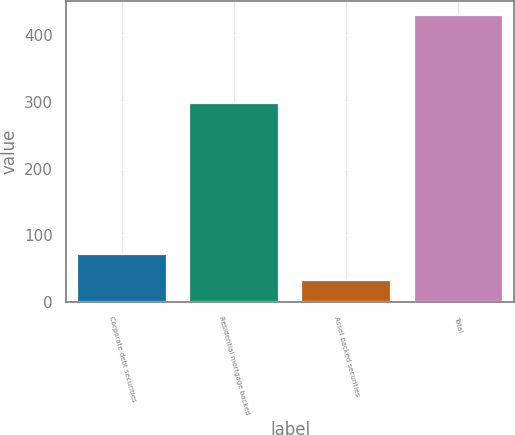Convert chart. <chart><loc_0><loc_0><loc_500><loc_500><bar_chart><fcel>Corporate debt securities<fcel>Residential mortgage backed<fcel>Asset backed securities<fcel>Total<nl><fcel>72.7<fcel>298<fcel>33<fcel>430<nl></chart> 